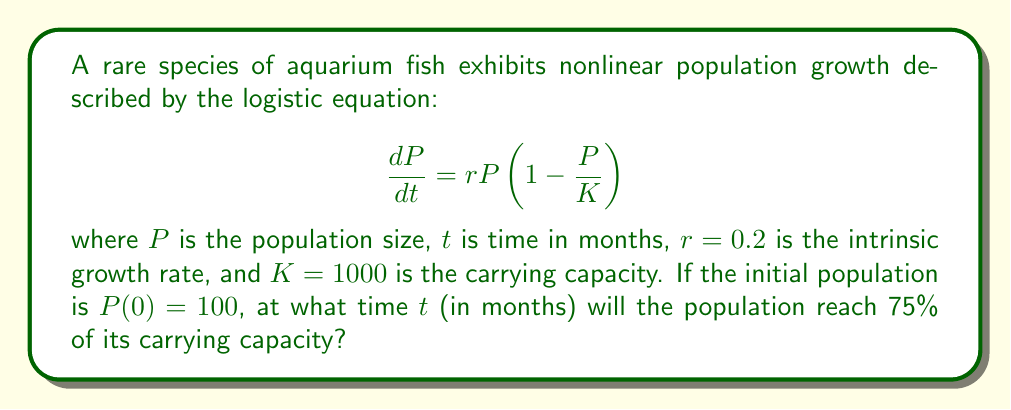Can you answer this question? To solve this problem, we'll follow these steps:

1) The logistic equation has the following solution:

   $$P(t) = \frac{K}{1 + \left(\frac{K}{P_0} - 1\right)e^{-rt}}$$

   where $P_0$ is the initial population.

2) We want to find $t$ when $P(t) = 0.75K = 750$. Let's substitute the known values:

   $$750 = \frac{1000}{1 + \left(\frac{1000}{100} - 1\right)e^{-0.2t}}$$

3) Simplify:

   $$750 = \frac{1000}{1 + 9e^{-0.2t}}$$

4) Multiply both sides by $(1 + 9e^{-0.2t})$:

   $$750(1 + 9e^{-0.2t}) = 1000$$

5) Expand:

   $$750 + 6750e^{-0.2t} = 1000$$

6) Subtract 750 from both sides:

   $$6750e^{-0.2t} = 250$$

7) Divide both sides by 6750:

   $$e^{-0.2t} = \frac{1}{27}$$

8) Take the natural log of both sides:

   $$-0.2t = \ln\left(\frac{1}{27}\right) = -\ln(27)$$

9) Divide both sides by -0.2:

   $$t = \frac{\ln(27)}{0.2} \approx 16.53$$

Therefore, the population will reach 75% of its carrying capacity after approximately 16.53 months.
Answer: 16.53 months 